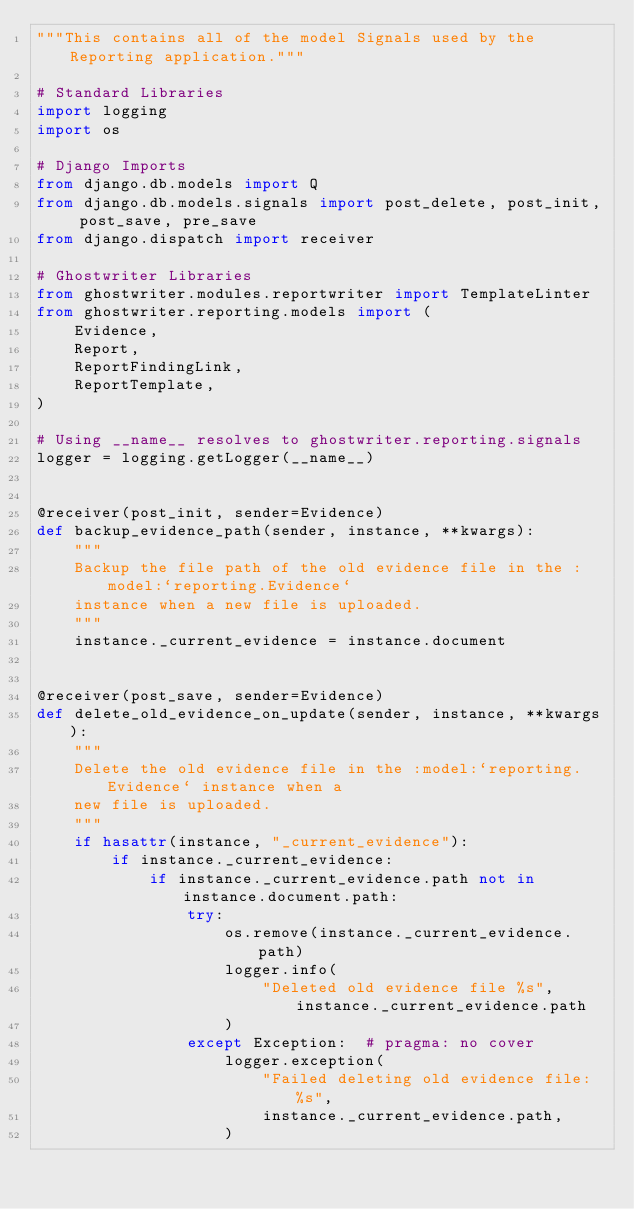<code> <loc_0><loc_0><loc_500><loc_500><_Python_>"""This contains all of the model Signals used by the Reporting application."""

# Standard Libraries
import logging
import os

# Django Imports
from django.db.models import Q
from django.db.models.signals import post_delete, post_init, post_save, pre_save
from django.dispatch import receiver

# Ghostwriter Libraries
from ghostwriter.modules.reportwriter import TemplateLinter
from ghostwriter.reporting.models import (
    Evidence,
    Report,
    ReportFindingLink,
    ReportTemplate,
)

# Using __name__ resolves to ghostwriter.reporting.signals
logger = logging.getLogger(__name__)


@receiver(post_init, sender=Evidence)
def backup_evidence_path(sender, instance, **kwargs):
    """
    Backup the file path of the old evidence file in the :model:`reporting.Evidence`
    instance when a new file is uploaded.
    """
    instance._current_evidence = instance.document


@receiver(post_save, sender=Evidence)
def delete_old_evidence_on_update(sender, instance, **kwargs):
    """
    Delete the old evidence file in the :model:`reporting.Evidence` instance when a
    new file is uploaded.
    """
    if hasattr(instance, "_current_evidence"):
        if instance._current_evidence:
            if instance._current_evidence.path not in instance.document.path:
                try:
                    os.remove(instance._current_evidence.path)
                    logger.info(
                        "Deleted old evidence file %s", instance._current_evidence.path
                    )
                except Exception:  # pragma: no cover
                    logger.exception(
                        "Failed deleting old evidence file: %s",
                        instance._current_evidence.path,
                    )

</code> 